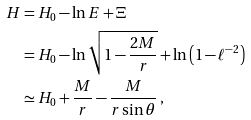Convert formula to latex. <formula><loc_0><loc_0><loc_500><loc_500>H & = H _ { 0 } - \ln E + \Xi \\ & = H _ { 0 } - \ln \sqrt { 1 - \frac { 2 M } { r } } + \ln \left ( 1 - \ell ^ { - 2 } \right ) \\ & \simeq H _ { 0 } + \frac { M } { r } - \frac { M } { r \sin \theta } \, ,</formula> 